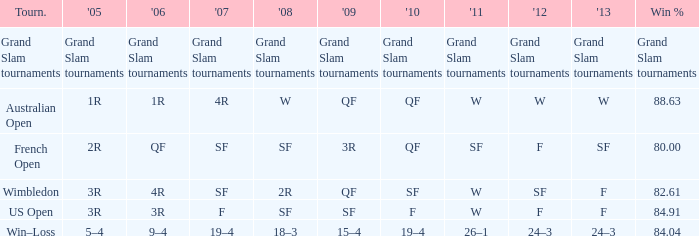What in 2007 has a 2010 of qf, and a 2012 of w? 4R. 